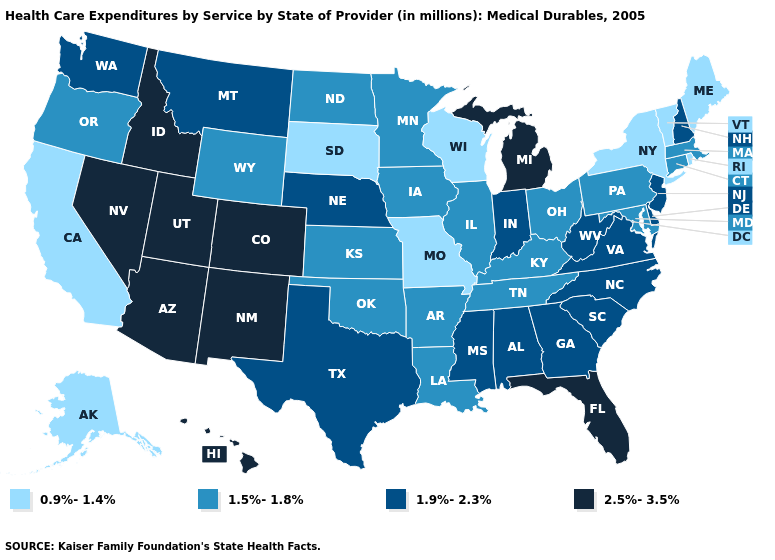What is the lowest value in the USA?
Be succinct. 0.9%-1.4%. Name the states that have a value in the range 0.9%-1.4%?
Short answer required. Alaska, California, Maine, Missouri, New York, Rhode Island, South Dakota, Vermont, Wisconsin. Among the states that border Michigan , does Ohio have the highest value?
Write a very short answer. No. Which states have the lowest value in the USA?
Be succinct. Alaska, California, Maine, Missouri, New York, Rhode Island, South Dakota, Vermont, Wisconsin. Does Arizona have the highest value in the West?
Be succinct. Yes. What is the value of Georgia?
Be succinct. 1.9%-2.3%. Does the map have missing data?
Write a very short answer. No. What is the value of Montana?
Give a very brief answer. 1.9%-2.3%. Which states hav the highest value in the MidWest?
Quick response, please. Michigan. Name the states that have a value in the range 1.9%-2.3%?
Write a very short answer. Alabama, Delaware, Georgia, Indiana, Mississippi, Montana, Nebraska, New Hampshire, New Jersey, North Carolina, South Carolina, Texas, Virginia, Washington, West Virginia. What is the lowest value in states that border Arizona?
Quick response, please. 0.9%-1.4%. What is the value of New Jersey?
Quick response, please. 1.9%-2.3%. What is the value of Georgia?
Write a very short answer. 1.9%-2.3%. What is the value of Illinois?
Concise answer only. 1.5%-1.8%. What is the value of New York?
Give a very brief answer. 0.9%-1.4%. 